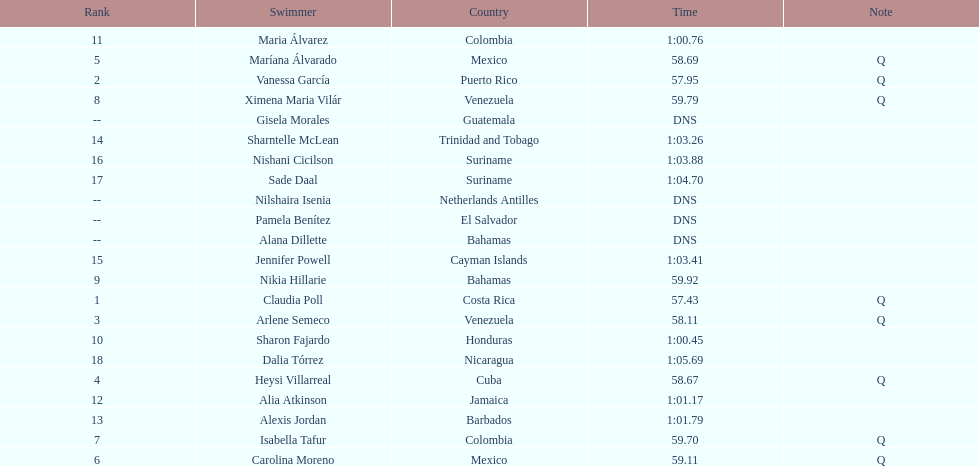How many swimmers are from mexico? 2. 